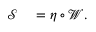Convert formula to latex. <formula><loc_0><loc_0><loc_500><loc_500>\begin{array} { r l } { \mathcal { S } } & = \eta \circ \mathcal { W } . } \end{array}</formula> 